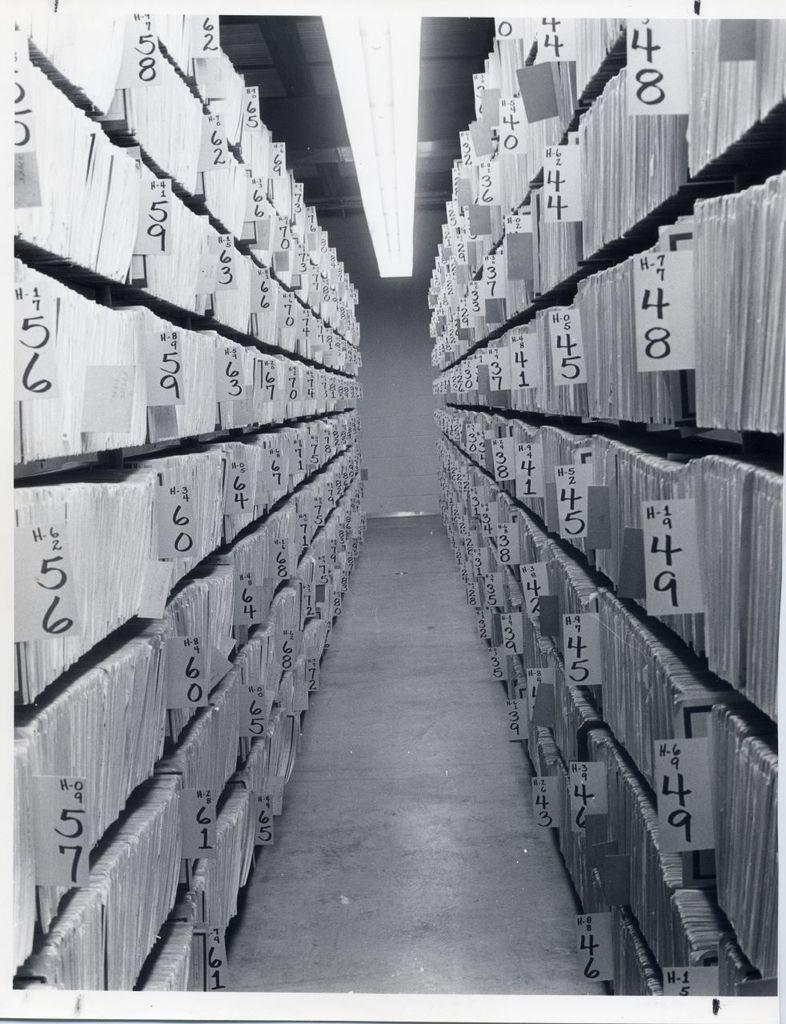What is written on the papers in the image? There are numbers written on the papers in the image. Can you describe the light visible in the image? Unfortunately, the provided facts do not give any details about the light, so we cannot describe it. What type of crayon is being used to write letters on the papers in the image? There is no crayon or letters present in the image; only papers with numbers written on them are visible. 